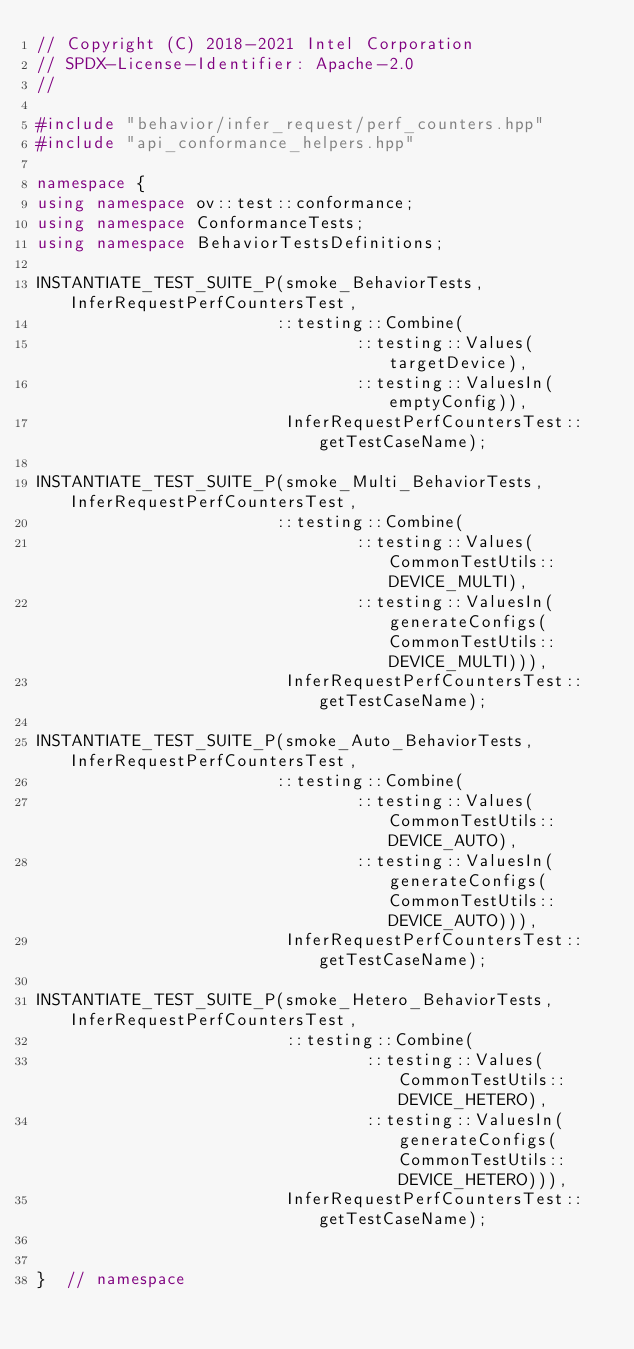Convert code to text. <code><loc_0><loc_0><loc_500><loc_500><_C++_>// Copyright (C) 2018-2021 Intel Corporation
// SPDX-License-Identifier: Apache-2.0
//

#include "behavior/infer_request/perf_counters.hpp"
#include "api_conformance_helpers.hpp"

namespace {
using namespace ov::test::conformance;
using namespace ConformanceTests;
using namespace BehaviorTestsDefinitions;

INSTANTIATE_TEST_SUITE_P(smoke_BehaviorTests, InferRequestPerfCountersTest,
                        ::testing::Combine(
                                ::testing::Values(targetDevice),
                                ::testing::ValuesIn(emptyConfig)),
                         InferRequestPerfCountersTest::getTestCaseName);

INSTANTIATE_TEST_SUITE_P(smoke_Multi_BehaviorTests, InferRequestPerfCountersTest,
                        ::testing::Combine(
                                ::testing::Values(CommonTestUtils::DEVICE_MULTI),
                                ::testing::ValuesIn(generateConfigs(CommonTestUtils::DEVICE_MULTI))),
                         InferRequestPerfCountersTest::getTestCaseName);

INSTANTIATE_TEST_SUITE_P(smoke_Auto_BehaviorTests, InferRequestPerfCountersTest,
                        ::testing::Combine(
                                ::testing::Values(CommonTestUtils::DEVICE_AUTO),
                                ::testing::ValuesIn(generateConfigs(CommonTestUtils::DEVICE_AUTO))),
                         InferRequestPerfCountersTest::getTestCaseName);

INSTANTIATE_TEST_SUITE_P(smoke_Hetero_BehaviorTests, InferRequestPerfCountersTest,
                         ::testing::Combine(
                                 ::testing::Values(CommonTestUtils::DEVICE_HETERO),
                                 ::testing::ValuesIn(generateConfigs(CommonTestUtils::DEVICE_HETERO))),
                         InferRequestPerfCountersTest::getTestCaseName);


}  // namespace
</code> 